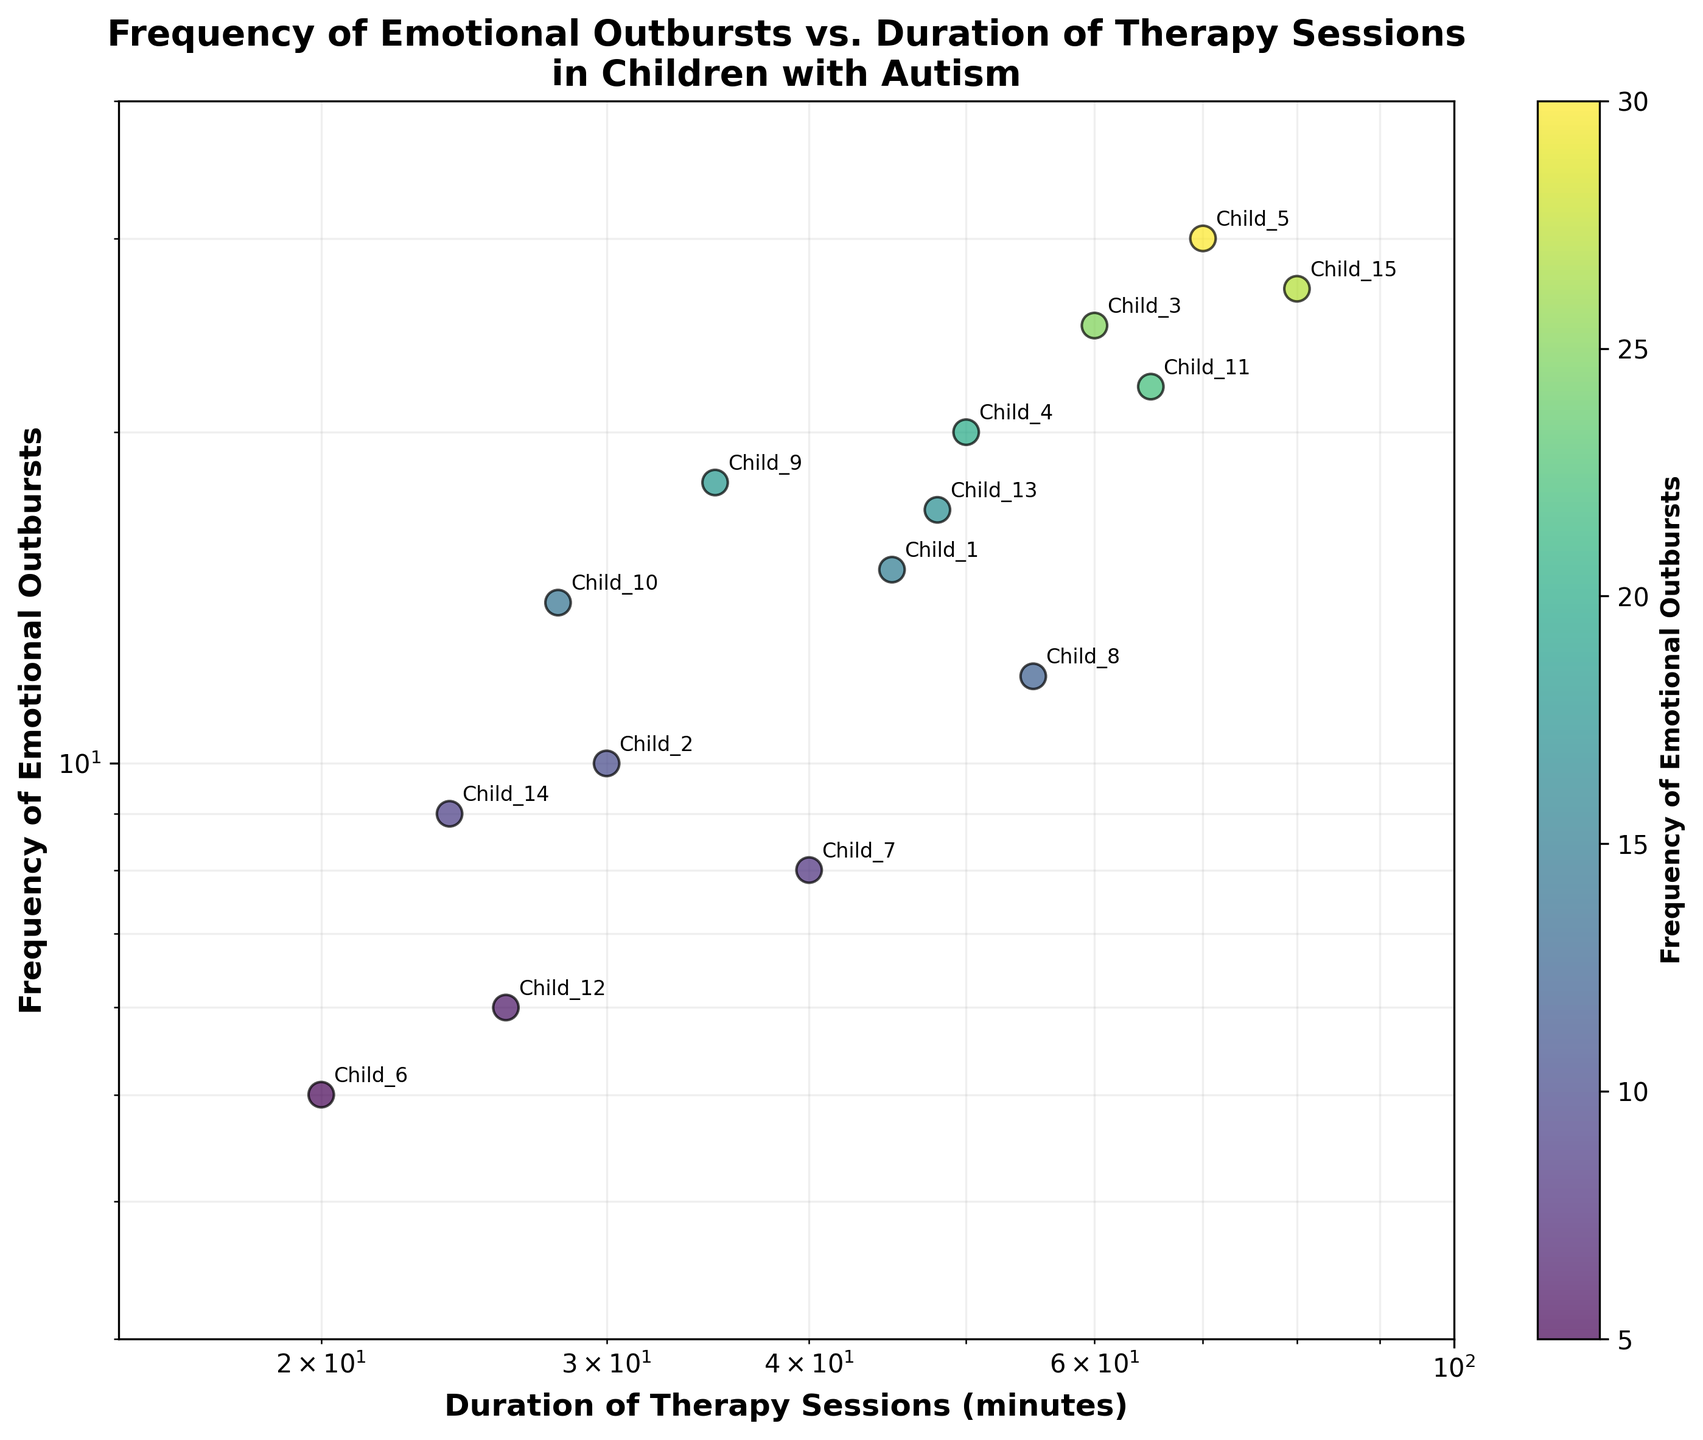What's the title of the figure? The title is displayed at the top of the figure. It reads "Frequency of Emotional Outbursts vs. Duration of Therapy Sessions in Children with Autism."
Answer: "Frequency of Emotional Outbursts vs. Duration of Therapy Sessions in Children with Autism" What are the labels for the x-axis and y-axis? The labels of the axes are displayed next to the respective axes. The x-axis is labeled "Duration of Therapy Sessions (minutes)" and the y-axis is labeled "Frequency of Emotional Outbursts."
Answer: "Duration of Therapy Sessions (minutes)" and "Frequency of Emotional Outbursts" How many data points are represented in the figure? Each data point represents a child's therapy session and emotional outbursts. Counting the points in the scatter plot, there are a total of 15 data points.
Answer: 15 What color scale is used for the scatter plot and what does it represent? The color scale is shown in the color bar to the right of the plot. It uses the "viridis" colormap and represents the frequency of emotional outbursts.
Answer: "viridis" colormap representing the frequency of emotional outbursts Which child had the highest frequency of emotional outbursts and what was their therapy session duration? By observing the scatter plot, the highest frequency of emotional outbursts is 30. This corresponds to Child_5, and the duration of their therapy session was 70 minutes.
Answer: Child_5, 70 minutes Is there an overall trend between the duration of therapy sessions and the frequency of emotional outbursts? By visually examining the scatter plot, it appears that with longer durations of therapy sessions, the frequency of emotional outbursts tends to increase, showing a positive correlation.
Answer: Positive correlation Which child had the shortest duration of therapy sessions, and how frequently did they have emotional outbursts? In the scatter plot, the shortest duration of therapy sessions was 20 minutes. This corresponds to Child_6, who had 5 emotional outbursts.
Answer: Child_6, 5 outbursts What is the approximate range of durations for therapy sessions shown in the figure? The x-axis spans from around 20 minutes to approximately 80 minutes based on the log scale used.
Answer: 20 to 80 minutes Compare the frequency of emotional outbursts of Child_12 and Child_14. By observing the scatter plot and annotations, Child_12 had 6 emotional outbursts, while Child_14 had 9 emotional outbursts.
Answer: Child_14 had more outbursts than Child_12 